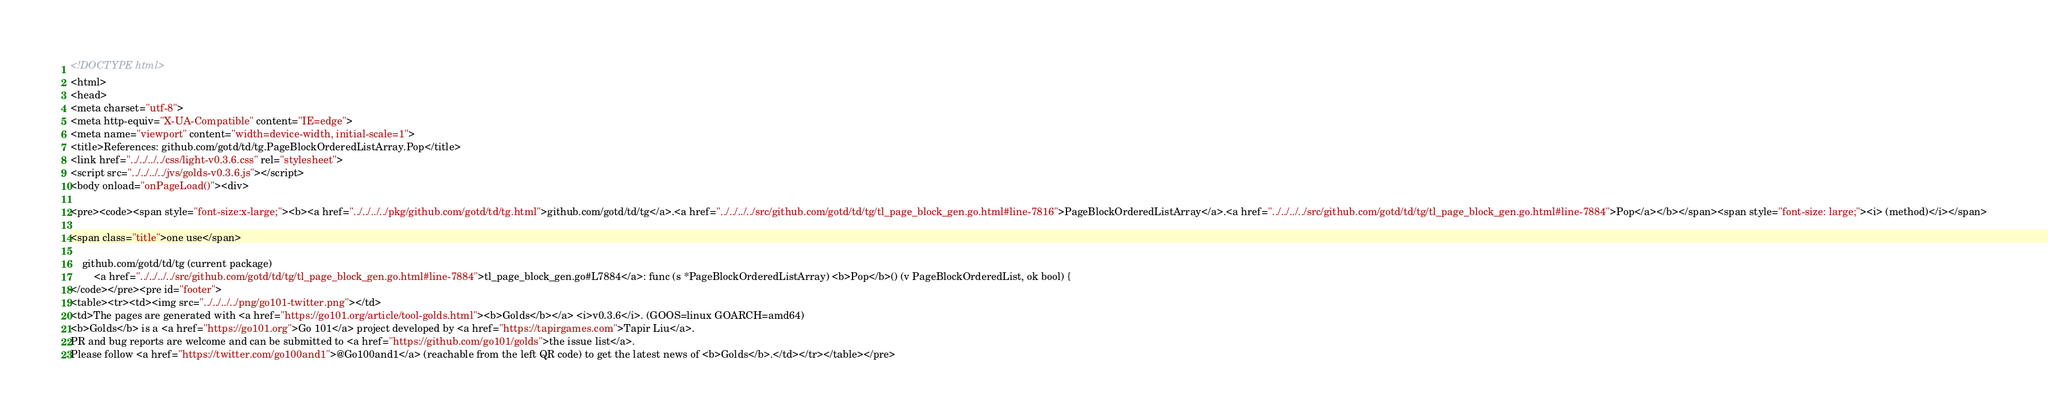<code> <loc_0><loc_0><loc_500><loc_500><_HTML_><!DOCTYPE html>
<html>
<head>
<meta charset="utf-8">
<meta http-equiv="X-UA-Compatible" content="IE=edge">
<meta name="viewport" content="width=device-width, initial-scale=1">
<title>References: github.com/gotd/td/tg.PageBlockOrderedListArray.Pop</title>
<link href="../../../../css/light-v0.3.6.css" rel="stylesheet">
<script src="../../../../jvs/golds-v0.3.6.js"></script>
<body onload="onPageLoad()"><div>

<pre><code><span style="font-size:x-large;"><b><a href="../../../../pkg/github.com/gotd/td/tg.html">github.com/gotd/td/tg</a>.<a href="../../../../src/github.com/gotd/td/tg/tl_page_block_gen.go.html#line-7816">PageBlockOrderedListArray</a>.<a href="../../../../src/github.com/gotd/td/tg/tl_page_block_gen.go.html#line-7884">Pop</a></b></span><span style="font-size: large;"><i> (method)</i></span>

<span class="title">one use</span>

	github.com/gotd/td/tg (current package)
		<a href="../../../../src/github.com/gotd/td/tg/tl_page_block_gen.go.html#line-7884">tl_page_block_gen.go#L7884</a>: func (s *PageBlockOrderedListArray) <b>Pop</b>() (v PageBlockOrderedList, ok bool) {
</code></pre><pre id="footer">
<table><tr><td><img src="../../../../png/go101-twitter.png"></td>
<td>The pages are generated with <a href="https://go101.org/article/tool-golds.html"><b>Golds</b></a> <i>v0.3.6</i>. (GOOS=linux GOARCH=amd64)
<b>Golds</b> is a <a href="https://go101.org">Go 101</a> project developed by <a href="https://tapirgames.com">Tapir Liu</a>.
PR and bug reports are welcome and can be submitted to <a href="https://github.com/go101/golds">the issue list</a>.
Please follow <a href="https://twitter.com/go100and1">@Go100and1</a> (reachable from the left QR code) to get the latest news of <b>Golds</b>.</td></tr></table></pre></code> 